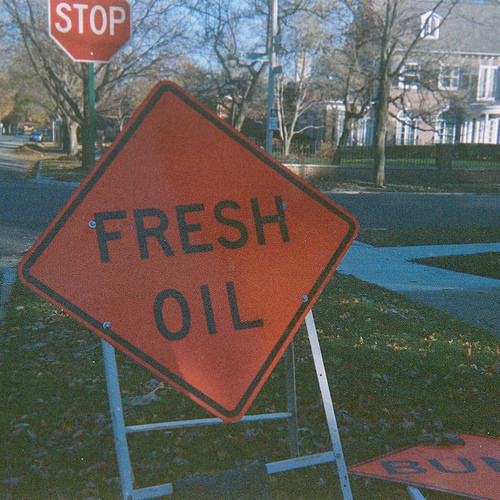<image>
Is there a sky behind the building? Yes. From this viewpoint, the sky is positioned behind the building, with the building partially or fully occluding the sky. 